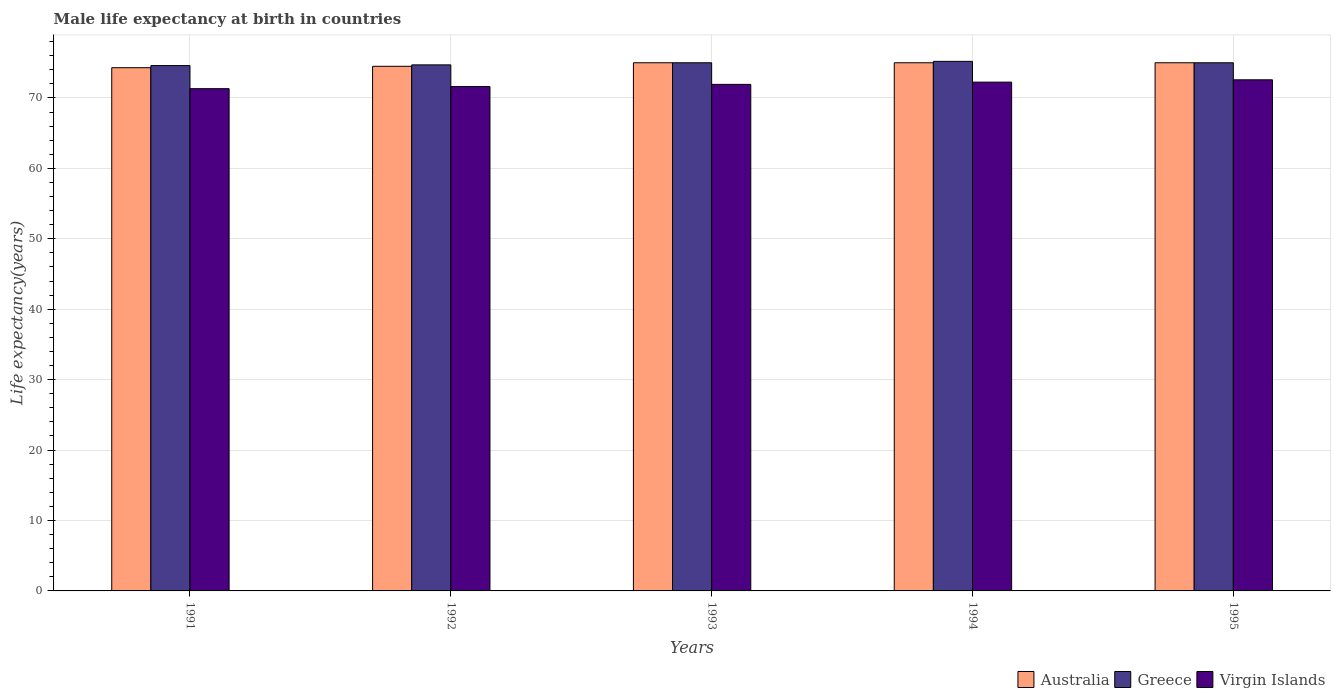How many different coloured bars are there?
Offer a very short reply. 3. Are the number of bars per tick equal to the number of legend labels?
Your answer should be very brief. Yes. Are the number of bars on each tick of the X-axis equal?
Make the answer very short. Yes. In how many cases, is the number of bars for a given year not equal to the number of legend labels?
Make the answer very short. 0. Across all years, what is the maximum male life expectancy at birth in Greece?
Ensure brevity in your answer.  75.2. Across all years, what is the minimum male life expectancy at birth in Virgin Islands?
Your answer should be compact. 71.32. In which year was the male life expectancy at birth in Virgin Islands maximum?
Provide a succinct answer. 1995. In which year was the male life expectancy at birth in Virgin Islands minimum?
Keep it short and to the point. 1991. What is the total male life expectancy at birth in Australia in the graph?
Your answer should be compact. 373.8. What is the difference between the male life expectancy at birth in Greece in 1991 and that in 1994?
Offer a terse response. -0.6. What is the difference between the male life expectancy at birth in Greece in 1993 and the male life expectancy at birth in Australia in 1991?
Your answer should be very brief. 0.7. What is the average male life expectancy at birth in Virgin Islands per year?
Offer a very short reply. 71.94. In the year 1992, what is the difference between the male life expectancy at birth in Virgin Islands and male life expectancy at birth in Greece?
Provide a short and direct response. -3.08. What is the ratio of the male life expectancy at birth in Australia in 1992 to that in 1995?
Keep it short and to the point. 0.99. Is the difference between the male life expectancy at birth in Virgin Islands in 1991 and 1992 greater than the difference between the male life expectancy at birth in Greece in 1991 and 1992?
Ensure brevity in your answer.  No. What is the difference between the highest and the second highest male life expectancy at birth in Virgin Islands?
Your answer should be very brief. 0.33. What is the difference between the highest and the lowest male life expectancy at birth in Greece?
Provide a succinct answer. 0.6. What does the 3rd bar from the left in 1994 represents?
Give a very brief answer. Virgin Islands. What does the 3rd bar from the right in 1991 represents?
Your response must be concise. Australia. Is it the case that in every year, the sum of the male life expectancy at birth in Australia and male life expectancy at birth in Greece is greater than the male life expectancy at birth in Virgin Islands?
Provide a succinct answer. Yes. Does the graph contain grids?
Keep it short and to the point. Yes. How are the legend labels stacked?
Provide a succinct answer. Horizontal. What is the title of the graph?
Make the answer very short. Male life expectancy at birth in countries. What is the label or title of the Y-axis?
Offer a terse response. Life expectancy(years). What is the Life expectancy(years) in Australia in 1991?
Provide a succinct answer. 74.3. What is the Life expectancy(years) of Greece in 1991?
Offer a very short reply. 74.6. What is the Life expectancy(years) in Virgin Islands in 1991?
Provide a succinct answer. 71.32. What is the Life expectancy(years) in Australia in 1992?
Provide a succinct answer. 74.5. What is the Life expectancy(years) in Greece in 1992?
Ensure brevity in your answer.  74.7. What is the Life expectancy(years) in Virgin Islands in 1992?
Offer a very short reply. 71.62. What is the Life expectancy(years) in Virgin Islands in 1993?
Your answer should be very brief. 71.93. What is the Life expectancy(years) of Greece in 1994?
Keep it short and to the point. 75.2. What is the Life expectancy(years) of Virgin Islands in 1994?
Keep it short and to the point. 72.25. What is the Life expectancy(years) in Australia in 1995?
Give a very brief answer. 75. What is the Life expectancy(years) of Virgin Islands in 1995?
Offer a terse response. 72.58. Across all years, what is the maximum Life expectancy(years) of Australia?
Provide a succinct answer. 75. Across all years, what is the maximum Life expectancy(years) of Greece?
Your response must be concise. 75.2. Across all years, what is the maximum Life expectancy(years) of Virgin Islands?
Offer a terse response. 72.58. Across all years, what is the minimum Life expectancy(years) in Australia?
Provide a short and direct response. 74.3. Across all years, what is the minimum Life expectancy(years) of Greece?
Your answer should be compact. 74.6. Across all years, what is the minimum Life expectancy(years) of Virgin Islands?
Ensure brevity in your answer.  71.32. What is the total Life expectancy(years) in Australia in the graph?
Offer a terse response. 373.8. What is the total Life expectancy(years) in Greece in the graph?
Provide a succinct answer. 374.5. What is the total Life expectancy(years) in Virgin Islands in the graph?
Offer a terse response. 359.7. What is the difference between the Life expectancy(years) of Australia in 1991 and that in 1992?
Your response must be concise. -0.2. What is the difference between the Life expectancy(years) of Virgin Islands in 1991 and that in 1992?
Provide a succinct answer. -0.3. What is the difference between the Life expectancy(years) in Greece in 1991 and that in 1993?
Ensure brevity in your answer.  -0.4. What is the difference between the Life expectancy(years) in Virgin Islands in 1991 and that in 1993?
Ensure brevity in your answer.  -0.61. What is the difference between the Life expectancy(years) of Australia in 1991 and that in 1994?
Provide a succinct answer. -0.7. What is the difference between the Life expectancy(years) in Greece in 1991 and that in 1994?
Keep it short and to the point. -0.6. What is the difference between the Life expectancy(years) in Virgin Islands in 1991 and that in 1994?
Your response must be concise. -0.93. What is the difference between the Life expectancy(years) of Australia in 1991 and that in 1995?
Your response must be concise. -0.7. What is the difference between the Life expectancy(years) in Virgin Islands in 1991 and that in 1995?
Keep it short and to the point. -1.26. What is the difference between the Life expectancy(years) in Virgin Islands in 1992 and that in 1993?
Provide a short and direct response. -0.31. What is the difference between the Life expectancy(years) of Australia in 1992 and that in 1994?
Provide a succinct answer. -0.5. What is the difference between the Life expectancy(years) of Greece in 1992 and that in 1994?
Your response must be concise. -0.5. What is the difference between the Life expectancy(years) of Virgin Islands in 1992 and that in 1994?
Make the answer very short. -0.63. What is the difference between the Life expectancy(years) of Australia in 1992 and that in 1995?
Provide a short and direct response. -0.5. What is the difference between the Life expectancy(years) of Greece in 1992 and that in 1995?
Your response must be concise. -0.3. What is the difference between the Life expectancy(years) in Virgin Islands in 1992 and that in 1995?
Keep it short and to the point. -0.96. What is the difference between the Life expectancy(years) in Australia in 1993 and that in 1994?
Offer a terse response. 0. What is the difference between the Life expectancy(years) in Greece in 1993 and that in 1994?
Offer a very short reply. -0.2. What is the difference between the Life expectancy(years) in Virgin Islands in 1993 and that in 1994?
Offer a very short reply. -0.32. What is the difference between the Life expectancy(years) in Australia in 1993 and that in 1995?
Your answer should be very brief. 0. What is the difference between the Life expectancy(years) of Greece in 1993 and that in 1995?
Your answer should be compact. 0. What is the difference between the Life expectancy(years) in Virgin Islands in 1993 and that in 1995?
Make the answer very short. -0.65. What is the difference between the Life expectancy(years) of Australia in 1994 and that in 1995?
Provide a succinct answer. 0. What is the difference between the Life expectancy(years) in Virgin Islands in 1994 and that in 1995?
Make the answer very short. -0.33. What is the difference between the Life expectancy(years) of Australia in 1991 and the Life expectancy(years) of Virgin Islands in 1992?
Your answer should be compact. 2.68. What is the difference between the Life expectancy(years) in Greece in 1991 and the Life expectancy(years) in Virgin Islands in 1992?
Make the answer very short. 2.98. What is the difference between the Life expectancy(years) in Australia in 1991 and the Life expectancy(years) in Greece in 1993?
Your response must be concise. -0.7. What is the difference between the Life expectancy(years) of Australia in 1991 and the Life expectancy(years) of Virgin Islands in 1993?
Your response must be concise. 2.37. What is the difference between the Life expectancy(years) of Greece in 1991 and the Life expectancy(years) of Virgin Islands in 1993?
Keep it short and to the point. 2.67. What is the difference between the Life expectancy(years) of Australia in 1991 and the Life expectancy(years) of Greece in 1994?
Offer a very short reply. -0.9. What is the difference between the Life expectancy(years) in Australia in 1991 and the Life expectancy(years) in Virgin Islands in 1994?
Your answer should be very brief. 2.05. What is the difference between the Life expectancy(years) in Greece in 1991 and the Life expectancy(years) in Virgin Islands in 1994?
Give a very brief answer. 2.35. What is the difference between the Life expectancy(years) of Australia in 1991 and the Life expectancy(years) of Virgin Islands in 1995?
Keep it short and to the point. 1.72. What is the difference between the Life expectancy(years) of Greece in 1991 and the Life expectancy(years) of Virgin Islands in 1995?
Ensure brevity in your answer.  2.02. What is the difference between the Life expectancy(years) in Australia in 1992 and the Life expectancy(years) in Virgin Islands in 1993?
Keep it short and to the point. 2.57. What is the difference between the Life expectancy(years) in Greece in 1992 and the Life expectancy(years) in Virgin Islands in 1993?
Provide a short and direct response. 2.77. What is the difference between the Life expectancy(years) in Australia in 1992 and the Life expectancy(years) in Greece in 1994?
Your answer should be compact. -0.7. What is the difference between the Life expectancy(years) of Australia in 1992 and the Life expectancy(years) of Virgin Islands in 1994?
Provide a short and direct response. 2.25. What is the difference between the Life expectancy(years) of Greece in 1992 and the Life expectancy(years) of Virgin Islands in 1994?
Your answer should be compact. 2.45. What is the difference between the Life expectancy(years) in Australia in 1992 and the Life expectancy(years) in Greece in 1995?
Provide a succinct answer. -0.5. What is the difference between the Life expectancy(years) in Australia in 1992 and the Life expectancy(years) in Virgin Islands in 1995?
Your response must be concise. 1.92. What is the difference between the Life expectancy(years) of Greece in 1992 and the Life expectancy(years) of Virgin Islands in 1995?
Offer a terse response. 2.12. What is the difference between the Life expectancy(years) of Australia in 1993 and the Life expectancy(years) of Virgin Islands in 1994?
Make the answer very short. 2.75. What is the difference between the Life expectancy(years) of Greece in 1993 and the Life expectancy(years) of Virgin Islands in 1994?
Offer a very short reply. 2.75. What is the difference between the Life expectancy(years) in Australia in 1993 and the Life expectancy(years) in Virgin Islands in 1995?
Provide a short and direct response. 2.42. What is the difference between the Life expectancy(years) of Greece in 1993 and the Life expectancy(years) of Virgin Islands in 1995?
Give a very brief answer. 2.42. What is the difference between the Life expectancy(years) of Australia in 1994 and the Life expectancy(years) of Greece in 1995?
Give a very brief answer. 0. What is the difference between the Life expectancy(years) in Australia in 1994 and the Life expectancy(years) in Virgin Islands in 1995?
Make the answer very short. 2.42. What is the difference between the Life expectancy(years) of Greece in 1994 and the Life expectancy(years) of Virgin Islands in 1995?
Give a very brief answer. 2.62. What is the average Life expectancy(years) in Australia per year?
Give a very brief answer. 74.76. What is the average Life expectancy(years) of Greece per year?
Ensure brevity in your answer.  74.9. What is the average Life expectancy(years) in Virgin Islands per year?
Offer a terse response. 71.94. In the year 1991, what is the difference between the Life expectancy(years) of Australia and Life expectancy(years) of Greece?
Offer a very short reply. -0.3. In the year 1991, what is the difference between the Life expectancy(years) of Australia and Life expectancy(years) of Virgin Islands?
Offer a very short reply. 2.98. In the year 1991, what is the difference between the Life expectancy(years) in Greece and Life expectancy(years) in Virgin Islands?
Your answer should be compact. 3.28. In the year 1992, what is the difference between the Life expectancy(years) in Australia and Life expectancy(years) in Greece?
Offer a terse response. -0.2. In the year 1992, what is the difference between the Life expectancy(years) of Australia and Life expectancy(years) of Virgin Islands?
Your response must be concise. 2.88. In the year 1992, what is the difference between the Life expectancy(years) of Greece and Life expectancy(years) of Virgin Islands?
Offer a terse response. 3.08. In the year 1993, what is the difference between the Life expectancy(years) of Australia and Life expectancy(years) of Virgin Islands?
Ensure brevity in your answer.  3.07. In the year 1993, what is the difference between the Life expectancy(years) of Greece and Life expectancy(years) of Virgin Islands?
Your response must be concise. 3.07. In the year 1994, what is the difference between the Life expectancy(years) of Australia and Life expectancy(years) of Virgin Islands?
Keep it short and to the point. 2.75. In the year 1994, what is the difference between the Life expectancy(years) in Greece and Life expectancy(years) in Virgin Islands?
Provide a short and direct response. 2.95. In the year 1995, what is the difference between the Life expectancy(years) in Australia and Life expectancy(years) in Greece?
Your response must be concise. 0. In the year 1995, what is the difference between the Life expectancy(years) of Australia and Life expectancy(years) of Virgin Islands?
Your answer should be compact. 2.42. In the year 1995, what is the difference between the Life expectancy(years) in Greece and Life expectancy(years) in Virgin Islands?
Offer a terse response. 2.42. What is the ratio of the Life expectancy(years) of Australia in 1991 to that in 1992?
Make the answer very short. 1. What is the ratio of the Life expectancy(years) of Greece in 1991 to that in 1992?
Make the answer very short. 1. What is the ratio of the Life expectancy(years) of Virgin Islands in 1991 to that in 1992?
Provide a short and direct response. 1. What is the ratio of the Life expectancy(years) in Australia in 1991 to that in 1993?
Keep it short and to the point. 0.99. What is the ratio of the Life expectancy(years) of Greece in 1991 to that in 1993?
Your response must be concise. 0.99. What is the ratio of the Life expectancy(years) in Virgin Islands in 1991 to that in 1993?
Ensure brevity in your answer.  0.99. What is the ratio of the Life expectancy(years) of Virgin Islands in 1991 to that in 1994?
Ensure brevity in your answer.  0.99. What is the ratio of the Life expectancy(years) of Virgin Islands in 1991 to that in 1995?
Ensure brevity in your answer.  0.98. What is the ratio of the Life expectancy(years) of Australia in 1992 to that in 1993?
Provide a short and direct response. 0.99. What is the ratio of the Life expectancy(years) in Virgin Islands in 1992 to that in 1993?
Your response must be concise. 1. What is the ratio of the Life expectancy(years) in Greece in 1992 to that in 1995?
Offer a terse response. 1. What is the ratio of the Life expectancy(years) of Australia in 1993 to that in 1994?
Keep it short and to the point. 1. What is the ratio of the Life expectancy(years) in Greece in 1993 to that in 1994?
Offer a terse response. 1. What is the ratio of the Life expectancy(years) in Australia in 1993 to that in 1995?
Your response must be concise. 1. What is the ratio of the Life expectancy(years) of Virgin Islands in 1993 to that in 1995?
Your answer should be very brief. 0.99. What is the ratio of the Life expectancy(years) in Virgin Islands in 1994 to that in 1995?
Offer a very short reply. 1. What is the difference between the highest and the second highest Life expectancy(years) in Australia?
Ensure brevity in your answer.  0. What is the difference between the highest and the second highest Life expectancy(years) in Virgin Islands?
Your answer should be compact. 0.33. What is the difference between the highest and the lowest Life expectancy(years) of Australia?
Give a very brief answer. 0.7. What is the difference between the highest and the lowest Life expectancy(years) in Virgin Islands?
Your response must be concise. 1.26. 